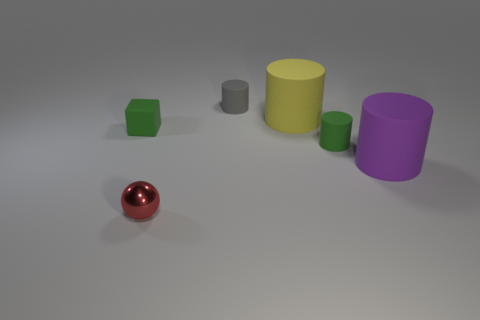Subtract all big yellow rubber cylinders. How many cylinders are left? 3 Subtract all purple cylinders. How many cylinders are left? 3 Add 2 yellow objects. How many objects exist? 8 Subtract all cubes. How many objects are left? 5 Add 5 tiny shiny spheres. How many tiny shiny spheres are left? 6 Add 4 tiny shiny balls. How many tiny shiny balls exist? 5 Subtract 0 cyan cylinders. How many objects are left? 6 Subtract all blue cylinders. Subtract all red balls. How many cylinders are left? 4 Subtract all tiny matte cylinders. Subtract all balls. How many objects are left? 3 